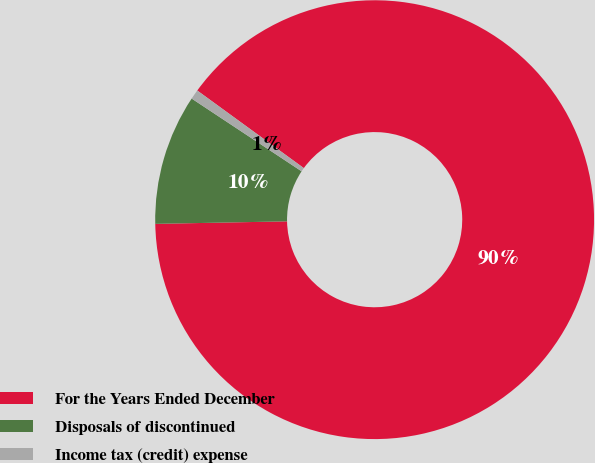Convert chart to OTSL. <chart><loc_0><loc_0><loc_500><loc_500><pie_chart><fcel>For the Years Ended December<fcel>Disposals of discontinued<fcel>Income tax (credit) expense<nl><fcel>89.68%<fcel>9.61%<fcel>0.71%<nl></chart> 